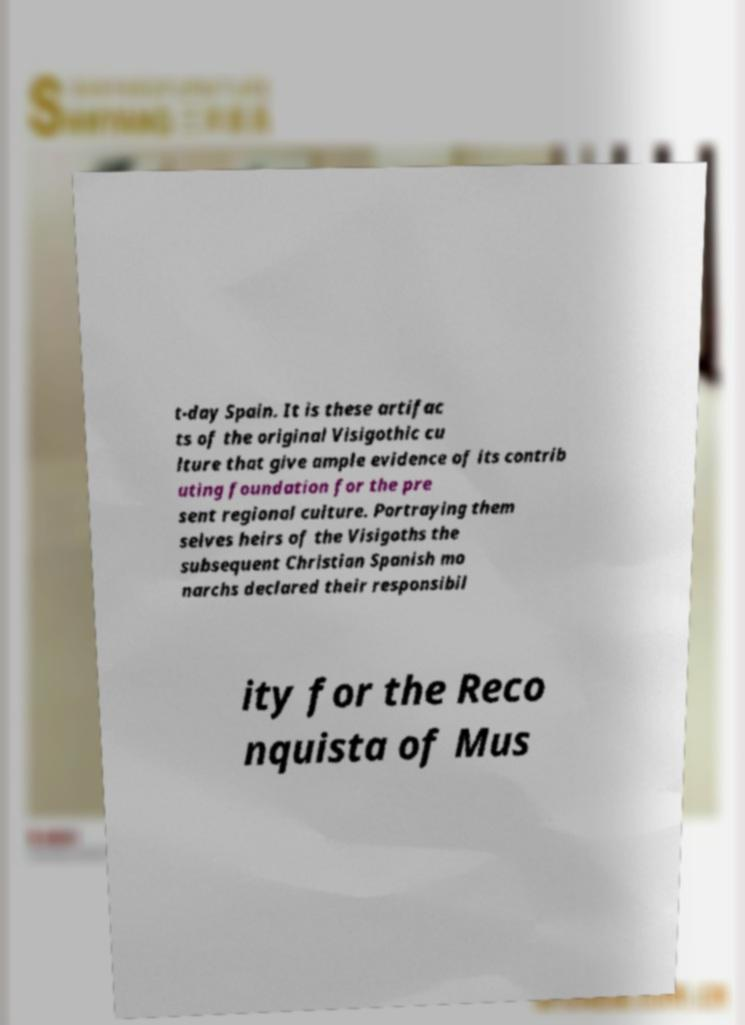There's text embedded in this image that I need extracted. Can you transcribe it verbatim? t-day Spain. It is these artifac ts of the original Visigothic cu lture that give ample evidence of its contrib uting foundation for the pre sent regional culture. Portraying them selves heirs of the Visigoths the subsequent Christian Spanish mo narchs declared their responsibil ity for the Reco nquista of Mus 